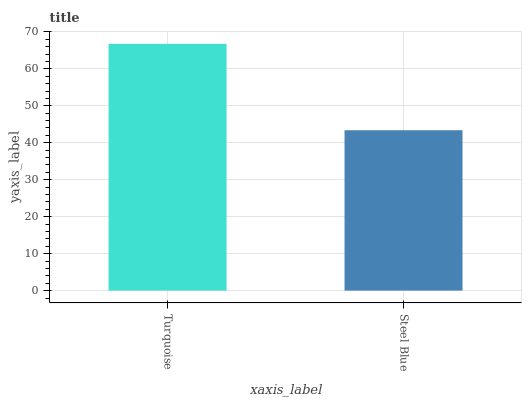Is Steel Blue the minimum?
Answer yes or no. Yes. Is Turquoise the maximum?
Answer yes or no. Yes. Is Steel Blue the maximum?
Answer yes or no. No. Is Turquoise greater than Steel Blue?
Answer yes or no. Yes. Is Steel Blue less than Turquoise?
Answer yes or no. Yes. Is Steel Blue greater than Turquoise?
Answer yes or no. No. Is Turquoise less than Steel Blue?
Answer yes or no. No. Is Turquoise the high median?
Answer yes or no. Yes. Is Steel Blue the low median?
Answer yes or no. Yes. Is Steel Blue the high median?
Answer yes or no. No. Is Turquoise the low median?
Answer yes or no. No. 